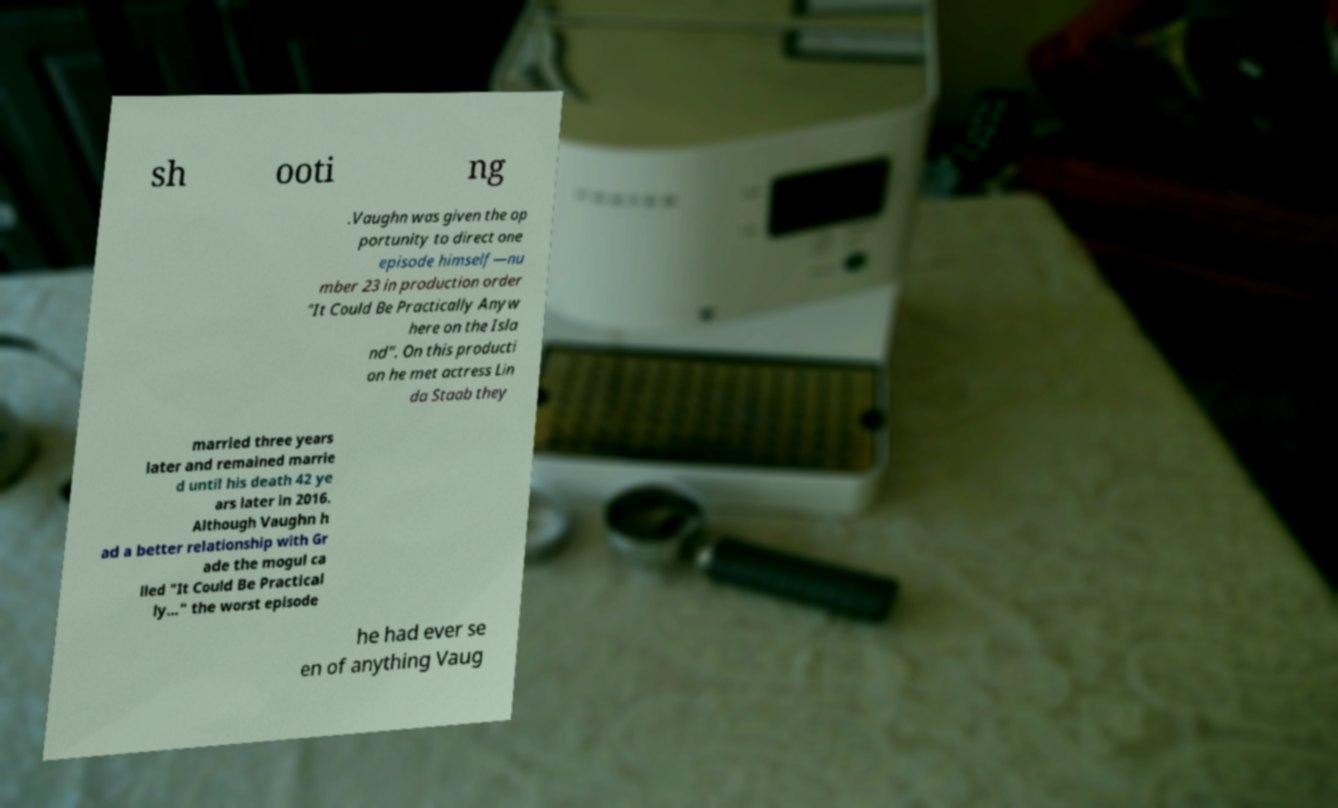Could you assist in decoding the text presented in this image and type it out clearly? sh ooti ng .Vaughn was given the op portunity to direct one episode himself—nu mber 23 in production order "It Could Be Practically Anyw here on the Isla nd". On this producti on he met actress Lin da Staab they married three years later and remained marrie d until his death 42 ye ars later in 2016. Although Vaughn h ad a better relationship with Gr ade the mogul ca lled "It Could Be Practical ly..." the worst episode he had ever se en of anything Vaug 